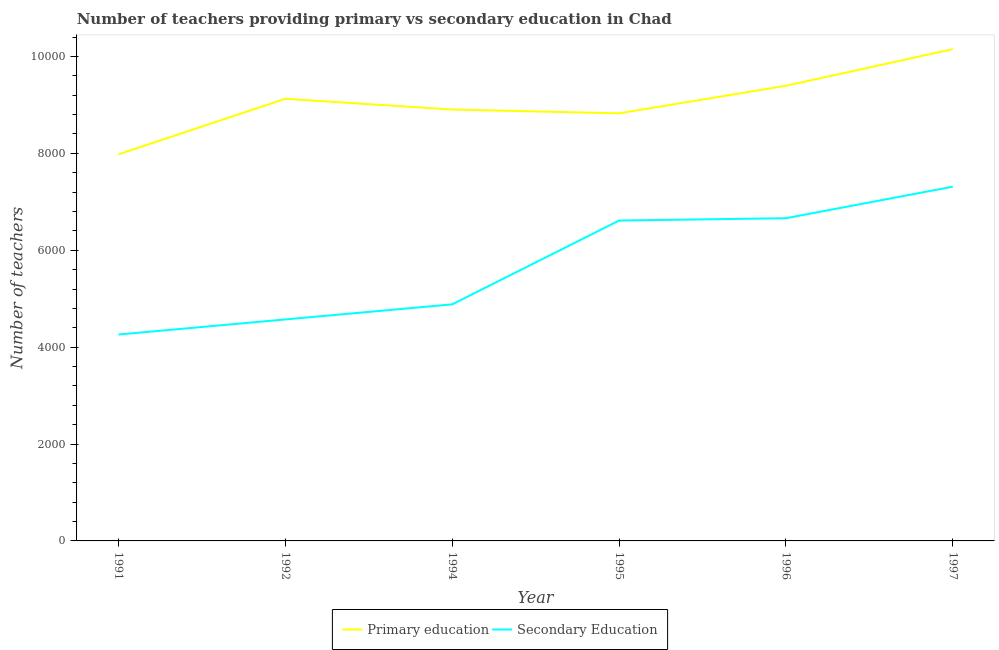How many different coloured lines are there?
Give a very brief answer. 2. Does the line corresponding to number of primary teachers intersect with the line corresponding to number of secondary teachers?
Offer a terse response. No. Is the number of lines equal to the number of legend labels?
Your response must be concise. Yes. What is the number of secondary teachers in 1997?
Offer a terse response. 7312. Across all years, what is the maximum number of primary teachers?
Provide a short and direct response. 1.02e+04. Across all years, what is the minimum number of primary teachers?
Your response must be concise. 7980. What is the total number of primary teachers in the graph?
Offer a terse response. 5.44e+04. What is the difference between the number of secondary teachers in 1991 and that in 1994?
Provide a short and direct response. -623. What is the difference between the number of primary teachers in 1996 and the number of secondary teachers in 1997?
Provide a short and direct response. 2083. What is the average number of primary teachers per year?
Provide a short and direct response. 9063.83. In the year 1992, what is the difference between the number of secondary teachers and number of primary teachers?
Keep it short and to the point. -4554. What is the ratio of the number of primary teachers in 1996 to that in 1997?
Make the answer very short. 0.93. Is the number of primary teachers in 1992 less than that in 1996?
Ensure brevity in your answer.  Yes. What is the difference between the highest and the second highest number of secondary teachers?
Provide a succinct answer. 651. What is the difference between the highest and the lowest number of primary teachers?
Provide a succinct answer. 2171. In how many years, is the number of primary teachers greater than the average number of primary teachers taken over all years?
Your response must be concise. 3. Is the sum of the number of secondary teachers in 1992 and 1997 greater than the maximum number of primary teachers across all years?
Make the answer very short. Yes. What is the difference between two consecutive major ticks on the Y-axis?
Your answer should be compact. 2000. Are the values on the major ticks of Y-axis written in scientific E-notation?
Give a very brief answer. No. Does the graph contain any zero values?
Provide a short and direct response. No. Does the graph contain grids?
Keep it short and to the point. No. How many legend labels are there?
Give a very brief answer. 2. What is the title of the graph?
Give a very brief answer. Number of teachers providing primary vs secondary education in Chad. What is the label or title of the X-axis?
Your answer should be very brief. Year. What is the label or title of the Y-axis?
Offer a very short reply. Number of teachers. What is the Number of teachers of Primary education in 1991?
Your answer should be very brief. 7980. What is the Number of teachers of Secondary Education in 1991?
Give a very brief answer. 4260. What is the Number of teachers in Primary education in 1992?
Your response must be concise. 9126. What is the Number of teachers of Secondary Education in 1992?
Your answer should be very brief. 4572. What is the Number of teachers of Primary education in 1994?
Make the answer very short. 8905. What is the Number of teachers of Secondary Education in 1994?
Ensure brevity in your answer.  4883. What is the Number of teachers of Primary education in 1995?
Ensure brevity in your answer.  8826. What is the Number of teachers of Secondary Education in 1995?
Your answer should be compact. 6613. What is the Number of teachers in Primary education in 1996?
Provide a short and direct response. 9395. What is the Number of teachers in Secondary Education in 1996?
Provide a short and direct response. 6661. What is the Number of teachers in Primary education in 1997?
Provide a short and direct response. 1.02e+04. What is the Number of teachers in Secondary Education in 1997?
Offer a terse response. 7312. Across all years, what is the maximum Number of teachers in Primary education?
Ensure brevity in your answer.  1.02e+04. Across all years, what is the maximum Number of teachers in Secondary Education?
Ensure brevity in your answer.  7312. Across all years, what is the minimum Number of teachers in Primary education?
Give a very brief answer. 7980. Across all years, what is the minimum Number of teachers of Secondary Education?
Your response must be concise. 4260. What is the total Number of teachers in Primary education in the graph?
Your answer should be very brief. 5.44e+04. What is the total Number of teachers in Secondary Education in the graph?
Make the answer very short. 3.43e+04. What is the difference between the Number of teachers of Primary education in 1991 and that in 1992?
Your answer should be very brief. -1146. What is the difference between the Number of teachers of Secondary Education in 1991 and that in 1992?
Your answer should be compact. -312. What is the difference between the Number of teachers in Primary education in 1991 and that in 1994?
Ensure brevity in your answer.  -925. What is the difference between the Number of teachers of Secondary Education in 1991 and that in 1994?
Provide a succinct answer. -623. What is the difference between the Number of teachers of Primary education in 1991 and that in 1995?
Give a very brief answer. -846. What is the difference between the Number of teachers in Secondary Education in 1991 and that in 1995?
Keep it short and to the point. -2353. What is the difference between the Number of teachers in Primary education in 1991 and that in 1996?
Keep it short and to the point. -1415. What is the difference between the Number of teachers in Secondary Education in 1991 and that in 1996?
Keep it short and to the point. -2401. What is the difference between the Number of teachers in Primary education in 1991 and that in 1997?
Provide a short and direct response. -2171. What is the difference between the Number of teachers in Secondary Education in 1991 and that in 1997?
Provide a succinct answer. -3052. What is the difference between the Number of teachers of Primary education in 1992 and that in 1994?
Give a very brief answer. 221. What is the difference between the Number of teachers in Secondary Education in 1992 and that in 1994?
Your answer should be compact. -311. What is the difference between the Number of teachers of Primary education in 1992 and that in 1995?
Provide a succinct answer. 300. What is the difference between the Number of teachers of Secondary Education in 1992 and that in 1995?
Offer a terse response. -2041. What is the difference between the Number of teachers in Primary education in 1992 and that in 1996?
Keep it short and to the point. -269. What is the difference between the Number of teachers of Secondary Education in 1992 and that in 1996?
Offer a very short reply. -2089. What is the difference between the Number of teachers in Primary education in 1992 and that in 1997?
Give a very brief answer. -1025. What is the difference between the Number of teachers of Secondary Education in 1992 and that in 1997?
Keep it short and to the point. -2740. What is the difference between the Number of teachers in Primary education in 1994 and that in 1995?
Provide a succinct answer. 79. What is the difference between the Number of teachers of Secondary Education in 1994 and that in 1995?
Your answer should be compact. -1730. What is the difference between the Number of teachers in Primary education in 1994 and that in 1996?
Provide a short and direct response. -490. What is the difference between the Number of teachers in Secondary Education in 1994 and that in 1996?
Keep it short and to the point. -1778. What is the difference between the Number of teachers of Primary education in 1994 and that in 1997?
Make the answer very short. -1246. What is the difference between the Number of teachers of Secondary Education in 1994 and that in 1997?
Your response must be concise. -2429. What is the difference between the Number of teachers in Primary education in 1995 and that in 1996?
Your answer should be very brief. -569. What is the difference between the Number of teachers in Secondary Education in 1995 and that in 1996?
Ensure brevity in your answer.  -48. What is the difference between the Number of teachers in Primary education in 1995 and that in 1997?
Make the answer very short. -1325. What is the difference between the Number of teachers in Secondary Education in 1995 and that in 1997?
Give a very brief answer. -699. What is the difference between the Number of teachers of Primary education in 1996 and that in 1997?
Give a very brief answer. -756. What is the difference between the Number of teachers of Secondary Education in 1996 and that in 1997?
Your answer should be compact. -651. What is the difference between the Number of teachers of Primary education in 1991 and the Number of teachers of Secondary Education in 1992?
Provide a succinct answer. 3408. What is the difference between the Number of teachers in Primary education in 1991 and the Number of teachers in Secondary Education in 1994?
Offer a terse response. 3097. What is the difference between the Number of teachers of Primary education in 1991 and the Number of teachers of Secondary Education in 1995?
Give a very brief answer. 1367. What is the difference between the Number of teachers in Primary education in 1991 and the Number of teachers in Secondary Education in 1996?
Ensure brevity in your answer.  1319. What is the difference between the Number of teachers in Primary education in 1991 and the Number of teachers in Secondary Education in 1997?
Offer a terse response. 668. What is the difference between the Number of teachers in Primary education in 1992 and the Number of teachers in Secondary Education in 1994?
Keep it short and to the point. 4243. What is the difference between the Number of teachers in Primary education in 1992 and the Number of teachers in Secondary Education in 1995?
Your answer should be very brief. 2513. What is the difference between the Number of teachers of Primary education in 1992 and the Number of teachers of Secondary Education in 1996?
Offer a terse response. 2465. What is the difference between the Number of teachers in Primary education in 1992 and the Number of teachers in Secondary Education in 1997?
Offer a very short reply. 1814. What is the difference between the Number of teachers in Primary education in 1994 and the Number of teachers in Secondary Education in 1995?
Give a very brief answer. 2292. What is the difference between the Number of teachers in Primary education in 1994 and the Number of teachers in Secondary Education in 1996?
Provide a short and direct response. 2244. What is the difference between the Number of teachers of Primary education in 1994 and the Number of teachers of Secondary Education in 1997?
Provide a succinct answer. 1593. What is the difference between the Number of teachers in Primary education in 1995 and the Number of teachers in Secondary Education in 1996?
Keep it short and to the point. 2165. What is the difference between the Number of teachers of Primary education in 1995 and the Number of teachers of Secondary Education in 1997?
Give a very brief answer. 1514. What is the difference between the Number of teachers in Primary education in 1996 and the Number of teachers in Secondary Education in 1997?
Provide a short and direct response. 2083. What is the average Number of teachers of Primary education per year?
Your response must be concise. 9063.83. What is the average Number of teachers of Secondary Education per year?
Offer a terse response. 5716.83. In the year 1991, what is the difference between the Number of teachers of Primary education and Number of teachers of Secondary Education?
Ensure brevity in your answer.  3720. In the year 1992, what is the difference between the Number of teachers in Primary education and Number of teachers in Secondary Education?
Make the answer very short. 4554. In the year 1994, what is the difference between the Number of teachers in Primary education and Number of teachers in Secondary Education?
Your response must be concise. 4022. In the year 1995, what is the difference between the Number of teachers of Primary education and Number of teachers of Secondary Education?
Your response must be concise. 2213. In the year 1996, what is the difference between the Number of teachers of Primary education and Number of teachers of Secondary Education?
Your answer should be compact. 2734. In the year 1997, what is the difference between the Number of teachers in Primary education and Number of teachers in Secondary Education?
Your response must be concise. 2839. What is the ratio of the Number of teachers of Primary education in 1991 to that in 1992?
Offer a terse response. 0.87. What is the ratio of the Number of teachers of Secondary Education in 1991 to that in 1992?
Keep it short and to the point. 0.93. What is the ratio of the Number of teachers in Primary education in 1991 to that in 1994?
Provide a short and direct response. 0.9. What is the ratio of the Number of teachers of Secondary Education in 1991 to that in 1994?
Make the answer very short. 0.87. What is the ratio of the Number of teachers in Primary education in 1991 to that in 1995?
Your answer should be very brief. 0.9. What is the ratio of the Number of teachers of Secondary Education in 1991 to that in 1995?
Provide a short and direct response. 0.64. What is the ratio of the Number of teachers in Primary education in 1991 to that in 1996?
Provide a succinct answer. 0.85. What is the ratio of the Number of teachers in Secondary Education in 1991 to that in 1996?
Keep it short and to the point. 0.64. What is the ratio of the Number of teachers in Primary education in 1991 to that in 1997?
Offer a very short reply. 0.79. What is the ratio of the Number of teachers in Secondary Education in 1991 to that in 1997?
Your answer should be compact. 0.58. What is the ratio of the Number of teachers of Primary education in 1992 to that in 1994?
Your response must be concise. 1.02. What is the ratio of the Number of teachers of Secondary Education in 1992 to that in 1994?
Your answer should be compact. 0.94. What is the ratio of the Number of teachers of Primary education in 1992 to that in 1995?
Your response must be concise. 1.03. What is the ratio of the Number of teachers in Secondary Education in 1992 to that in 1995?
Give a very brief answer. 0.69. What is the ratio of the Number of teachers in Primary education in 1992 to that in 1996?
Ensure brevity in your answer.  0.97. What is the ratio of the Number of teachers of Secondary Education in 1992 to that in 1996?
Offer a terse response. 0.69. What is the ratio of the Number of teachers of Primary education in 1992 to that in 1997?
Offer a very short reply. 0.9. What is the ratio of the Number of teachers in Secondary Education in 1992 to that in 1997?
Keep it short and to the point. 0.63. What is the ratio of the Number of teachers in Secondary Education in 1994 to that in 1995?
Give a very brief answer. 0.74. What is the ratio of the Number of teachers of Primary education in 1994 to that in 1996?
Provide a short and direct response. 0.95. What is the ratio of the Number of teachers of Secondary Education in 1994 to that in 1996?
Offer a terse response. 0.73. What is the ratio of the Number of teachers in Primary education in 1994 to that in 1997?
Give a very brief answer. 0.88. What is the ratio of the Number of teachers of Secondary Education in 1994 to that in 1997?
Make the answer very short. 0.67. What is the ratio of the Number of teachers of Primary education in 1995 to that in 1996?
Give a very brief answer. 0.94. What is the ratio of the Number of teachers of Primary education in 1995 to that in 1997?
Ensure brevity in your answer.  0.87. What is the ratio of the Number of teachers in Secondary Education in 1995 to that in 1997?
Offer a terse response. 0.9. What is the ratio of the Number of teachers in Primary education in 1996 to that in 1997?
Offer a terse response. 0.93. What is the ratio of the Number of teachers in Secondary Education in 1996 to that in 1997?
Ensure brevity in your answer.  0.91. What is the difference between the highest and the second highest Number of teachers of Primary education?
Offer a very short reply. 756. What is the difference between the highest and the second highest Number of teachers in Secondary Education?
Keep it short and to the point. 651. What is the difference between the highest and the lowest Number of teachers of Primary education?
Provide a short and direct response. 2171. What is the difference between the highest and the lowest Number of teachers in Secondary Education?
Offer a very short reply. 3052. 